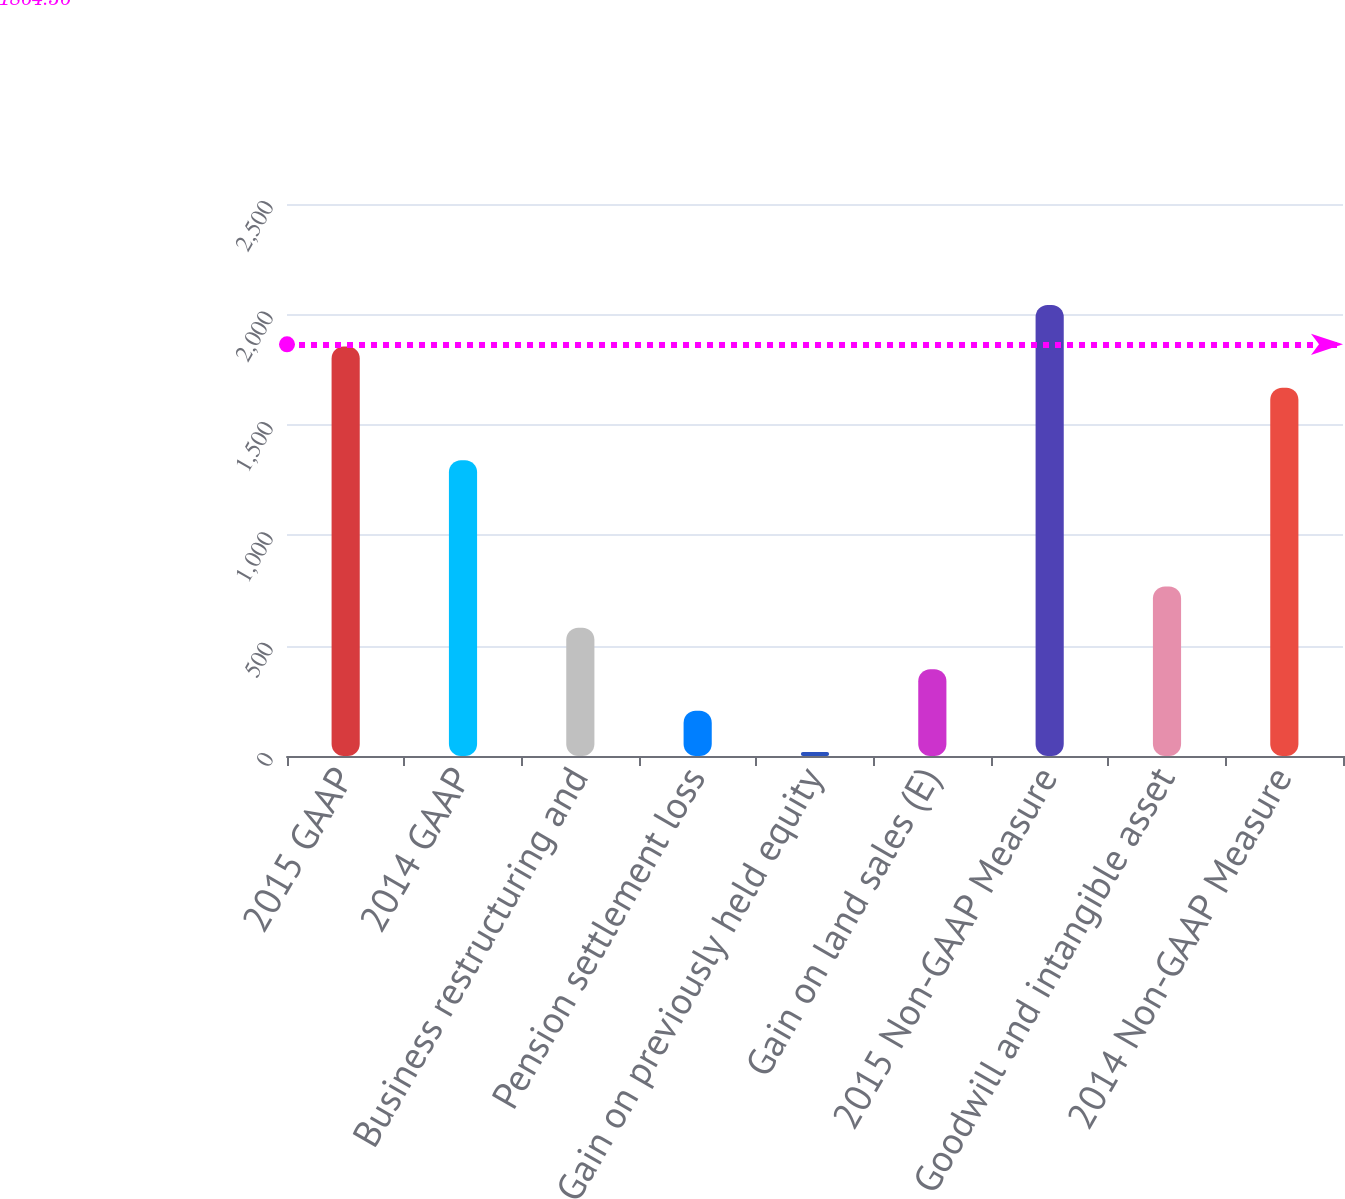Convert chart. <chart><loc_0><loc_0><loc_500><loc_500><bar_chart><fcel>2015 GAAP<fcel>2014 GAAP<fcel>Business restructuring and<fcel>Pension settlement loss<fcel>Gain on previously held equity<fcel>Gain on land sales (E)<fcel>2015 Non-GAAP Measure<fcel>Goodwill and intangible asset<fcel>2014 Non-GAAP Measure<nl><fcel>1854.93<fcel>1339.1<fcel>580.49<fcel>205.43<fcel>17.9<fcel>392.96<fcel>2042.46<fcel>768.02<fcel>1667.4<nl></chart> 